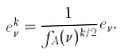Convert formula to latex. <formula><loc_0><loc_0><loc_500><loc_500>e _ { \nu } ^ { k } = \frac { 1 } { f _ { A } ( \nu ) ^ { k / 2 } } e _ { \nu } .</formula> 